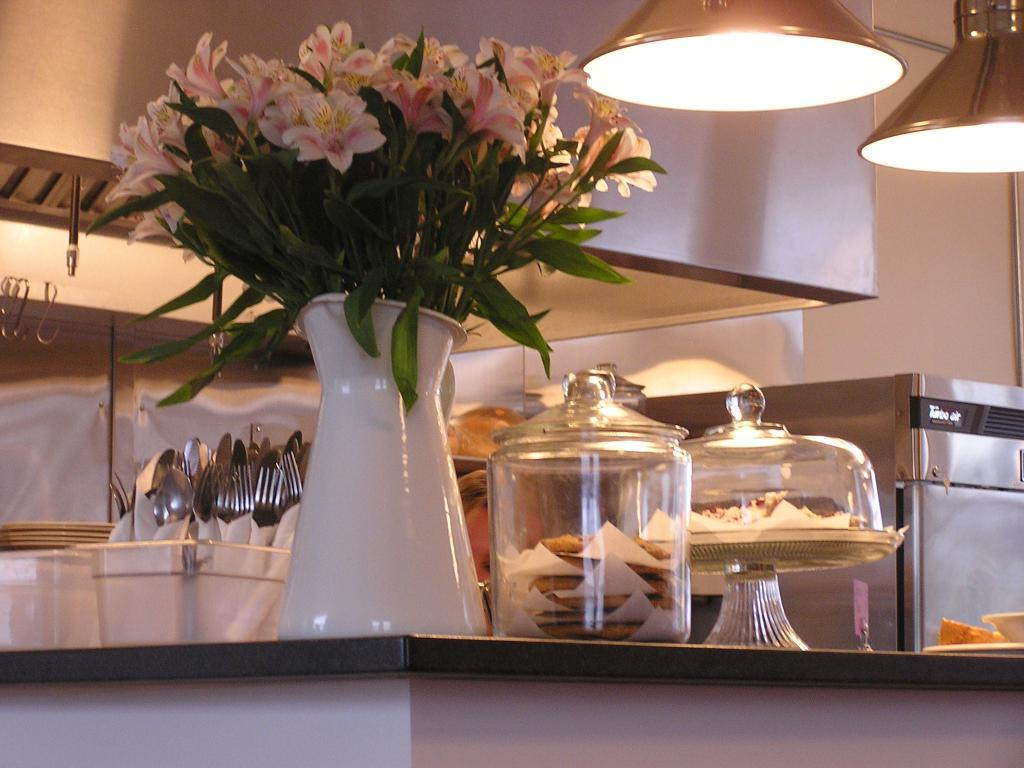What type of items can be seen in the image related to a kitchen? The image contains kitchen property items, such as spoons, forks, and a flower vase with flowers. What is the purpose of the flower vase in the image? The flower vase in the image is holding flowers, which adds a decorative element to the kitchen. What utensils are present in the image? Spoons and forks are present in the image. What type of food can be seen in the image? Garlic is visible in the image, and there is also food present. Where is the light located in the image? The light is on the right side of the image. What is the company's position on the wrist in the image? There is no company or wrist present in the image; it features kitchen property items and food. 